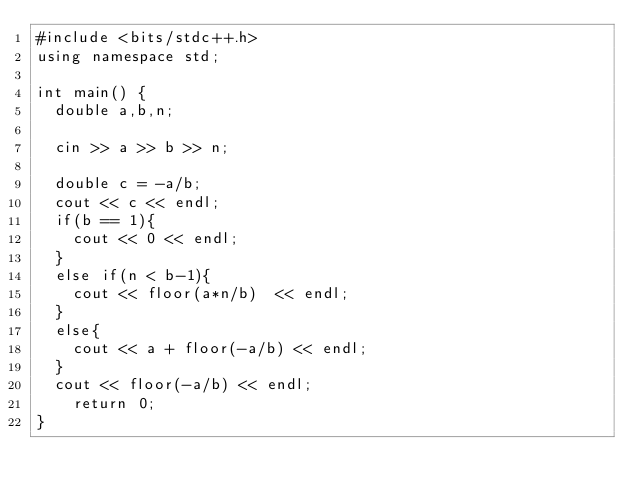Convert code to text. <code><loc_0><loc_0><loc_500><loc_500><_C++_>#include <bits/stdc++.h>
using namespace std;

int main() {
  double a,b,n;
  
  cin >> a >> b >> n;
  
  double c = -a/b;
  cout << c << endl;
  if(b == 1){
    cout << 0 << endl;
  }
  else if(n < b-1){
    cout << floor(a*n/b)  << endl;
  }
  else{
    cout << a + floor(-a/b) << endl;
  }
  cout << floor(-a/b) << endl;
	return 0;
}
</code> 